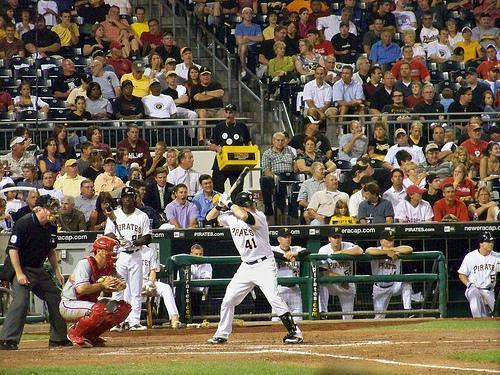How many Pirates baseball players are visible?
Give a very brief answer. 7. How many animals are pictured?
Give a very brief answer. 0. 